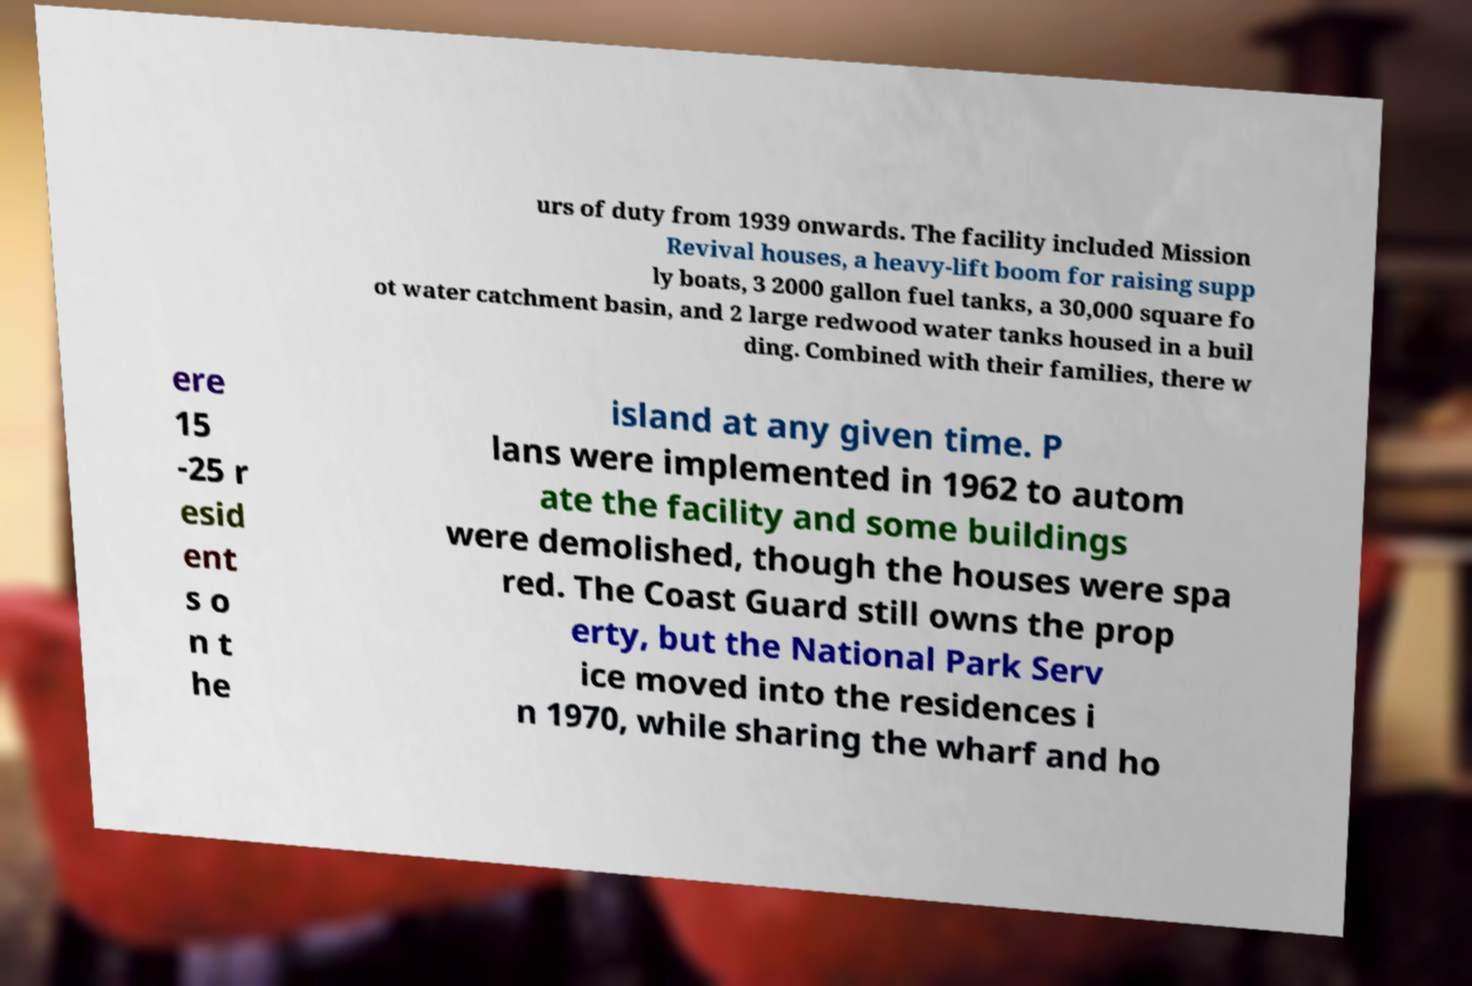Could you extract and type out the text from this image? urs of duty from 1939 onwards. The facility included Mission Revival houses, a heavy-lift boom for raising supp ly boats, 3 2000 gallon fuel tanks, a 30,000 square fo ot water catchment basin, and 2 large redwood water tanks housed in a buil ding. Combined with their families, there w ere 15 -25 r esid ent s o n t he island at any given time. P lans were implemented in 1962 to autom ate the facility and some buildings were demolished, though the houses were spa red. The Coast Guard still owns the prop erty, but the National Park Serv ice moved into the residences i n 1970, while sharing the wharf and ho 